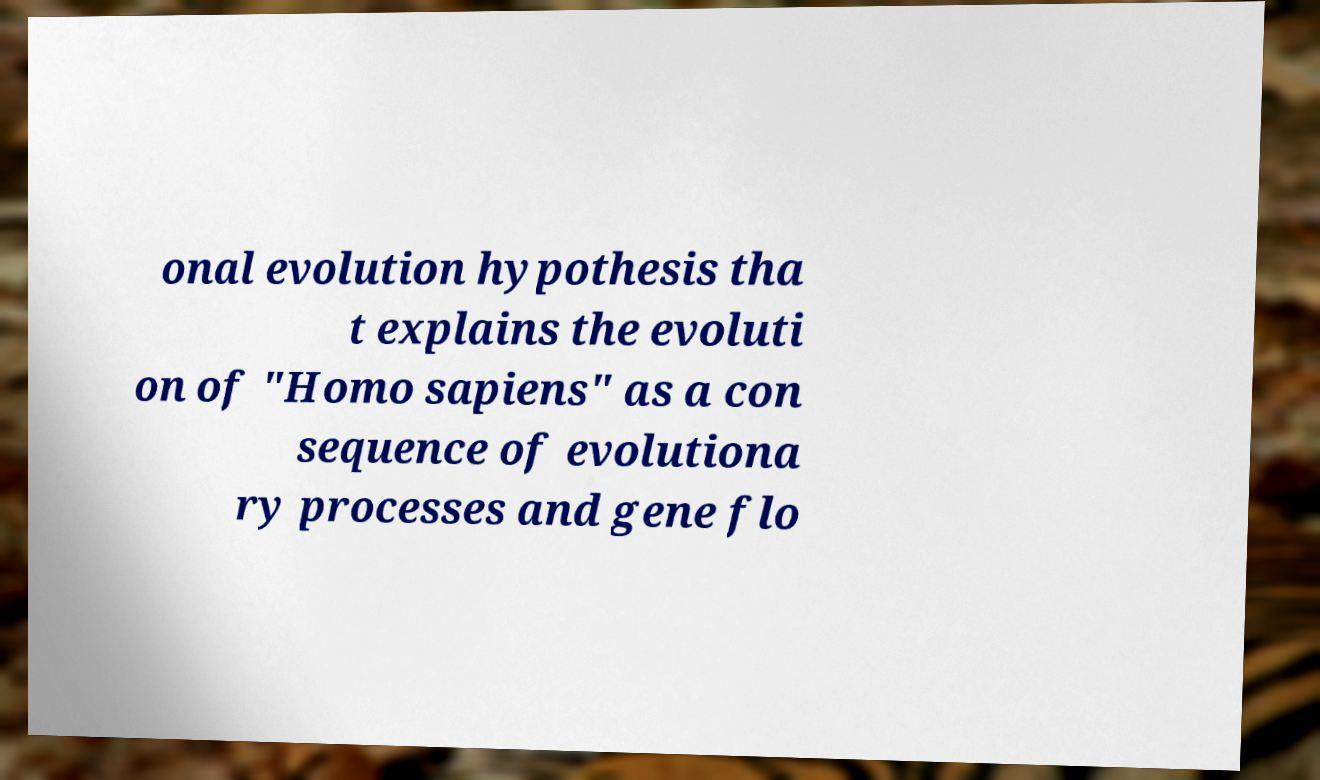Can you read and provide the text displayed in the image?This photo seems to have some interesting text. Can you extract and type it out for me? onal evolution hypothesis tha t explains the evoluti on of "Homo sapiens" as a con sequence of evolutiona ry processes and gene flo 